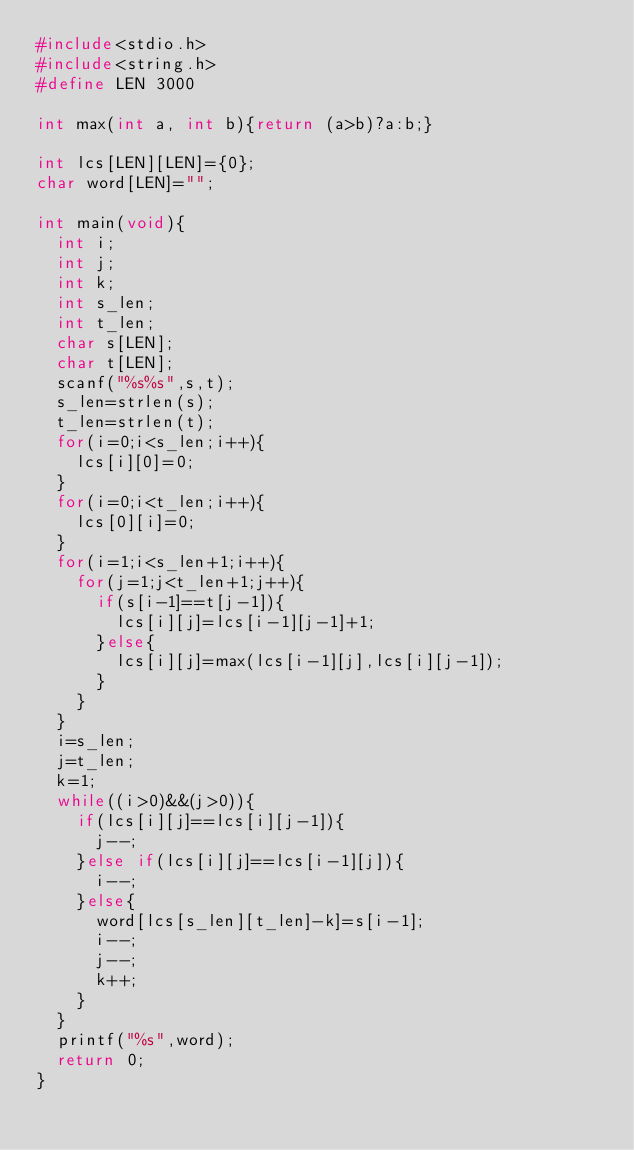Convert code to text. <code><loc_0><loc_0><loc_500><loc_500><_C_>#include<stdio.h>
#include<string.h>
#define LEN 3000

int max(int a, int b){return (a>b)?a:b;}

int lcs[LEN][LEN]={0};
char word[LEN]="";

int main(void){
	int i;
	int j;
	int k;
	int s_len;
	int t_len;
	char s[LEN];
	char t[LEN];
	scanf("%s%s",s,t);
	s_len=strlen(s);
	t_len=strlen(t);
	for(i=0;i<s_len;i++){
		lcs[i][0]=0;
	}
	for(i=0;i<t_len;i++){
		lcs[0][i]=0;
	}
	for(i=1;i<s_len+1;i++){
		for(j=1;j<t_len+1;j++){
			if(s[i-1]==t[j-1]){
				lcs[i][j]=lcs[i-1][j-1]+1;
			}else{
				lcs[i][j]=max(lcs[i-1][j],lcs[i][j-1]);
			}
		}
	}
	i=s_len;
	j=t_len;
	k=1;
	while((i>0)&&(j>0)){
		if(lcs[i][j]==lcs[i][j-1]){
			j--;
		}else if(lcs[i][j]==lcs[i-1][j]){
			i--;
		}else{
			word[lcs[s_len][t_len]-k]=s[i-1];
			i--;
			j--;
			k++;
		}
	}
	printf("%s",word);
	return 0;
}</code> 